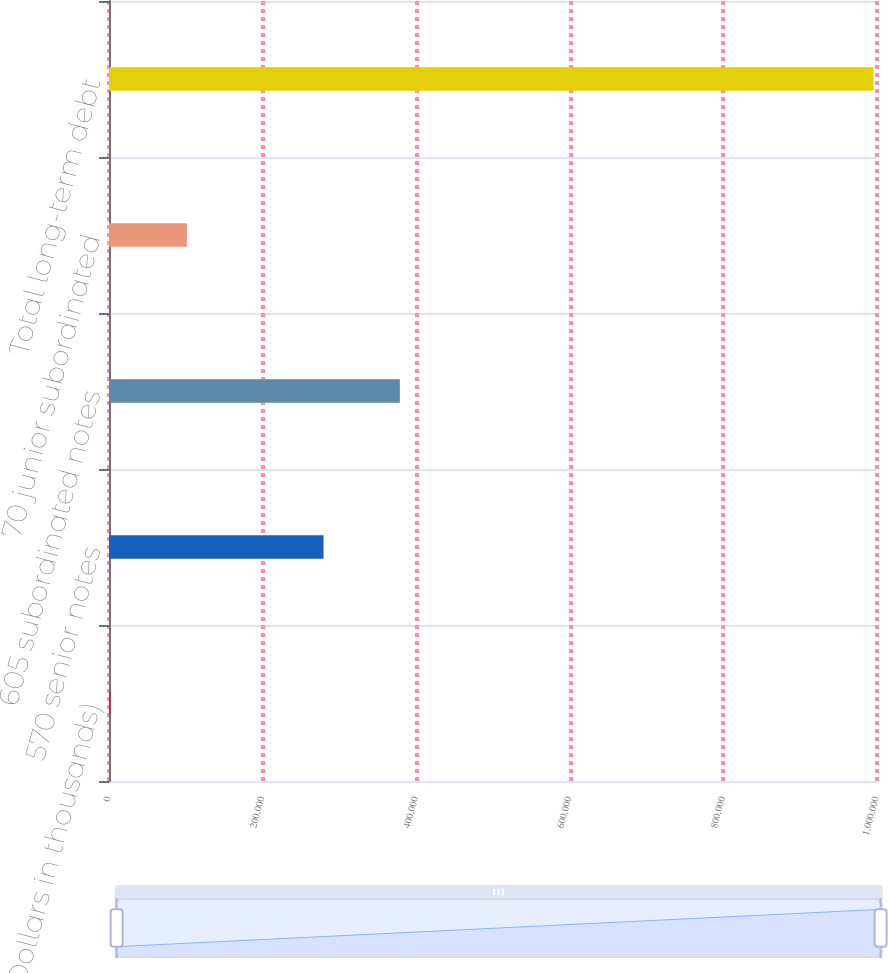<chart> <loc_0><loc_0><loc_500><loc_500><bar_chart><fcel>(Dollars in thousands)<fcel>570 senior notes<fcel>605 subordinated notes<fcel>70 junior subordinated<fcel>Total long-term debt<nl><fcel>2008<fcel>279370<fcel>378712<fcel>101350<fcel>995423<nl></chart> 